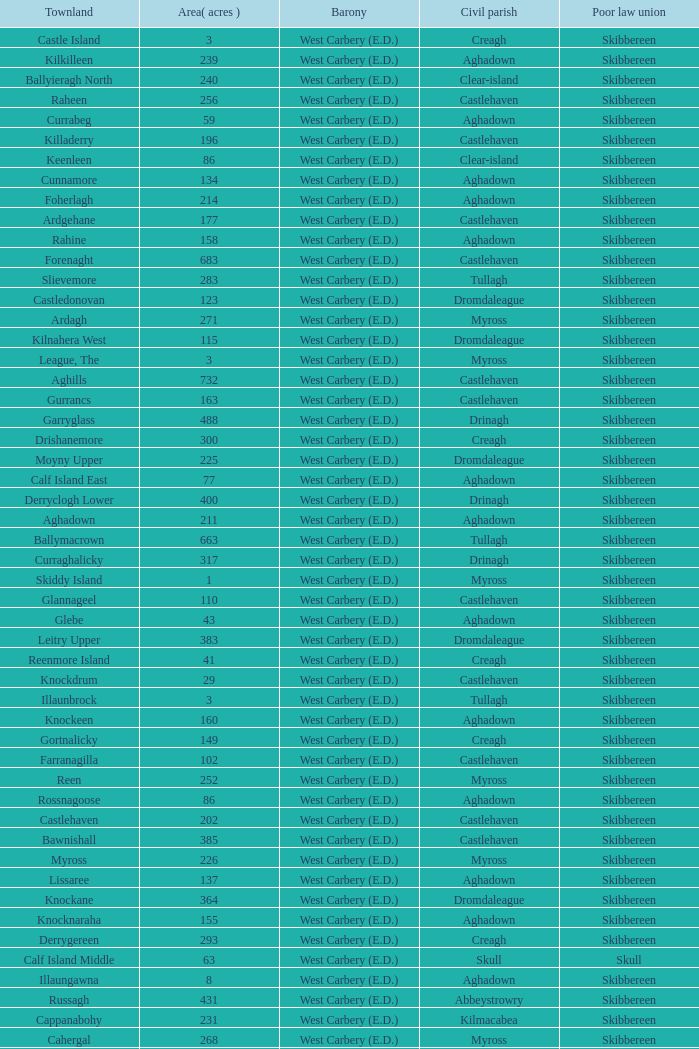What is the greatest area when the Poor Law Union is Skibbereen and the Civil Parish is Tullagh? 796.0. 